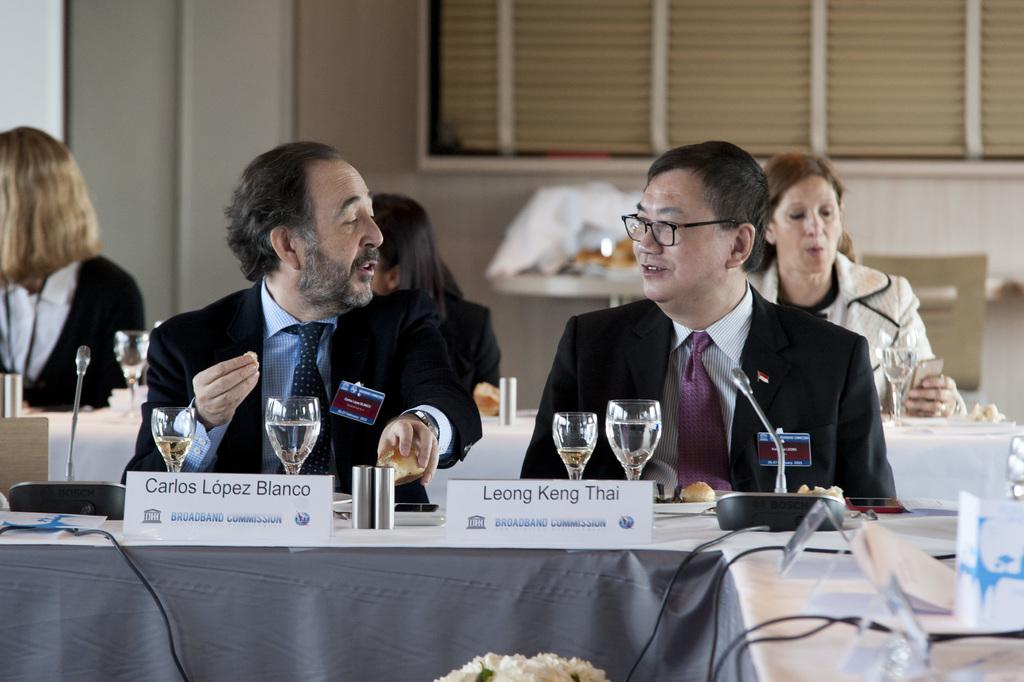<image>
Offer a succinct explanation of the picture presented. Carlos LópezBlanco is talking to Leong Keng Thai at a table. 